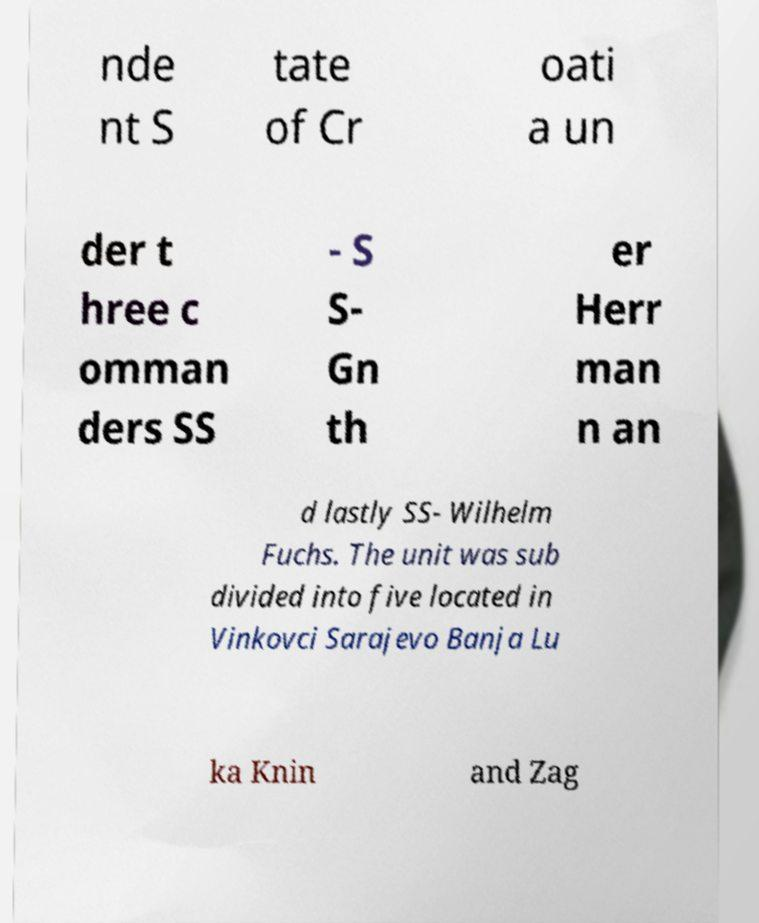Could you extract and type out the text from this image? nde nt S tate of Cr oati a un der t hree c omman ders SS - S S- Gn th er Herr man n an d lastly SS- Wilhelm Fuchs. The unit was sub divided into five located in Vinkovci Sarajevo Banja Lu ka Knin and Zag 